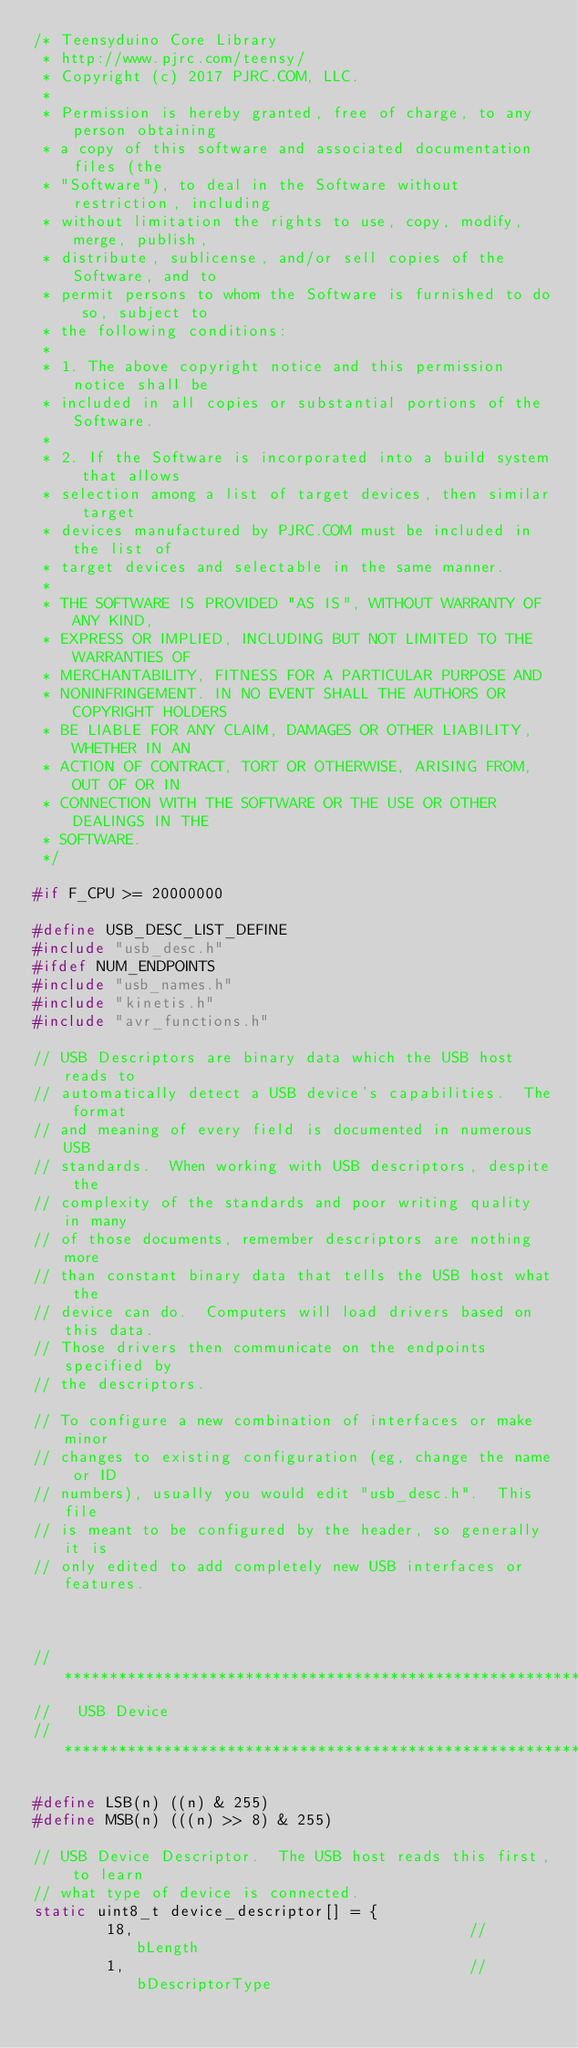<code> <loc_0><loc_0><loc_500><loc_500><_C_>/* Teensyduino Core Library
 * http://www.pjrc.com/teensy/
 * Copyright (c) 2017 PJRC.COM, LLC.
 *
 * Permission is hereby granted, free of charge, to any person obtaining
 * a copy of this software and associated documentation files (the
 * "Software"), to deal in the Software without restriction, including
 * without limitation the rights to use, copy, modify, merge, publish,
 * distribute, sublicense, and/or sell copies of the Software, and to
 * permit persons to whom the Software is furnished to do so, subject to
 * the following conditions:
 *
 * 1. The above copyright notice and this permission notice shall be
 * included in all copies or substantial portions of the Software.
 *
 * 2. If the Software is incorporated into a build system that allows
 * selection among a list of target devices, then similar target
 * devices manufactured by PJRC.COM must be included in the list of
 * target devices and selectable in the same manner.
 *
 * THE SOFTWARE IS PROVIDED "AS IS", WITHOUT WARRANTY OF ANY KIND,
 * EXPRESS OR IMPLIED, INCLUDING BUT NOT LIMITED TO THE WARRANTIES OF
 * MERCHANTABILITY, FITNESS FOR A PARTICULAR PURPOSE AND
 * NONINFRINGEMENT. IN NO EVENT SHALL THE AUTHORS OR COPYRIGHT HOLDERS
 * BE LIABLE FOR ANY CLAIM, DAMAGES OR OTHER LIABILITY, WHETHER IN AN
 * ACTION OF CONTRACT, TORT OR OTHERWISE, ARISING FROM, OUT OF OR IN
 * CONNECTION WITH THE SOFTWARE OR THE USE OR OTHER DEALINGS IN THE
 * SOFTWARE.
 */

#if F_CPU >= 20000000

#define USB_DESC_LIST_DEFINE
#include "usb_desc.h"
#ifdef NUM_ENDPOINTS
#include "usb_names.h"
#include "kinetis.h"
#include "avr_functions.h"

// USB Descriptors are binary data which the USB host reads to
// automatically detect a USB device's capabilities.  The format
// and meaning of every field is documented in numerous USB
// standards.  When working with USB descriptors, despite the
// complexity of the standards and poor writing quality in many
// of those documents, remember descriptors are nothing more
// than constant binary data that tells the USB host what the
// device can do.  Computers will load drivers based on this data.
// Those drivers then communicate on the endpoints specified by
// the descriptors.

// To configure a new combination of interfaces or make minor
// changes to existing configuration (eg, change the name or ID
// numbers), usually you would edit "usb_desc.h".  This file
// is meant to be configured by the header, so generally it is
// only edited to add completely new USB interfaces or features.



// **************************************************************
//   USB Device
// **************************************************************

#define LSB(n) ((n) & 255)
#define MSB(n) (((n) >> 8) & 255)

// USB Device Descriptor.  The USB host reads this first, to learn
// what type of device is connected.
static uint8_t device_descriptor[] = {
        18,                                     // bLength
        1,                                      // bDescriptorType</code> 